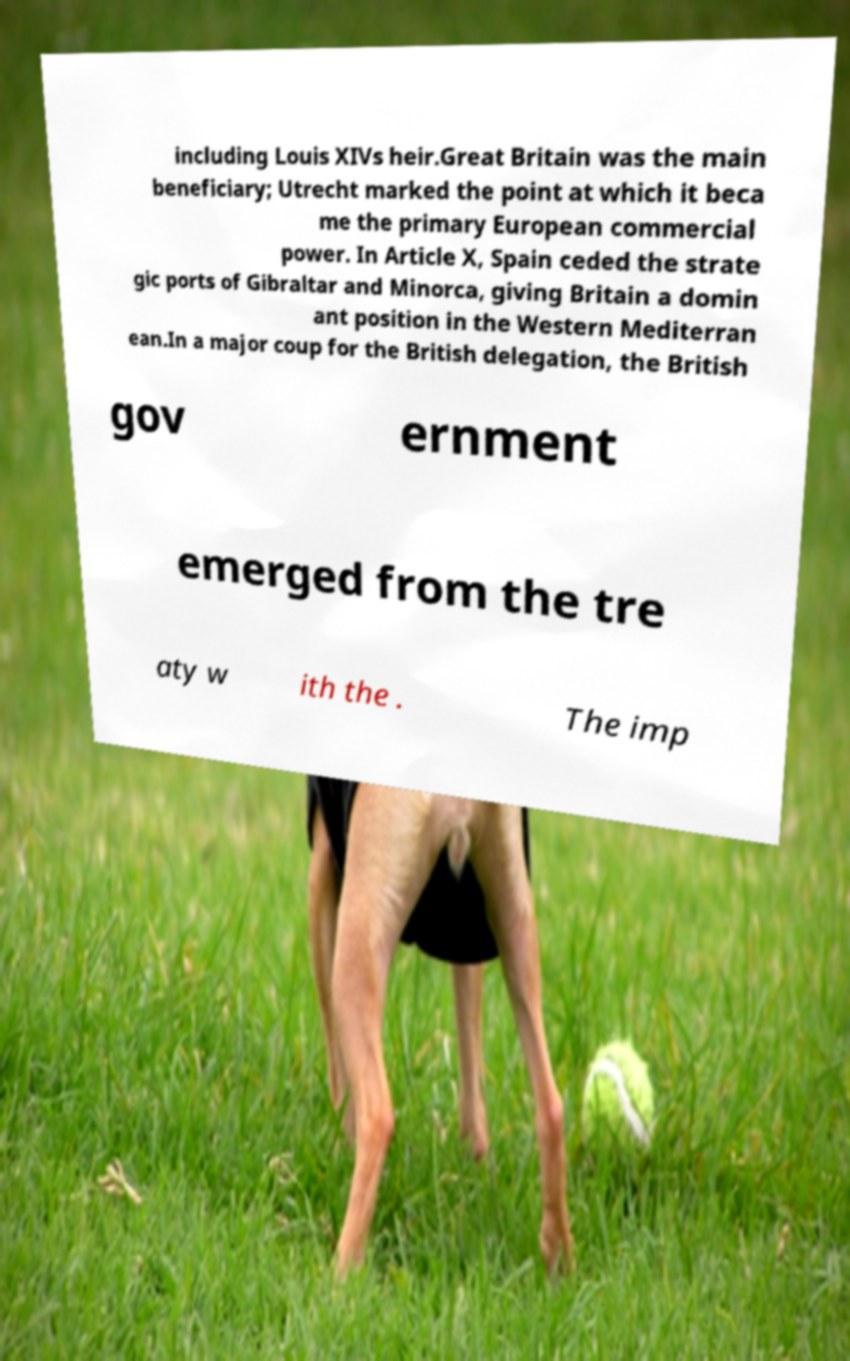Could you assist in decoding the text presented in this image and type it out clearly? including Louis XIVs heir.Great Britain was the main beneficiary; Utrecht marked the point at which it beca me the primary European commercial power. In Article X, Spain ceded the strate gic ports of Gibraltar and Minorca, giving Britain a domin ant position in the Western Mediterran ean.In a major coup for the British delegation, the British gov ernment emerged from the tre aty w ith the . The imp 